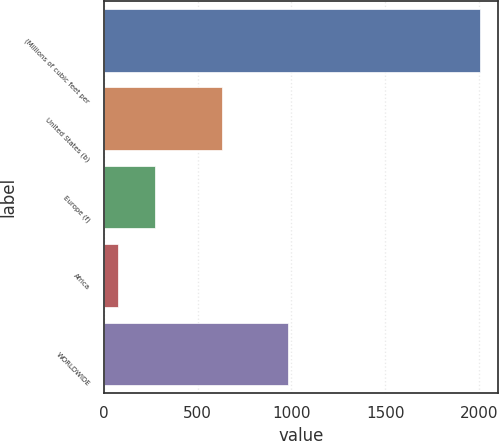Convert chart. <chart><loc_0><loc_0><loc_500><loc_500><bar_chart><fcel>(Millions of cubic feet per<fcel>United States (b)<fcel>Europe (f)<fcel>Africa<fcel>WORLDWIDE<nl><fcel>2004<fcel>631<fcel>273<fcel>76<fcel>980<nl></chart> 